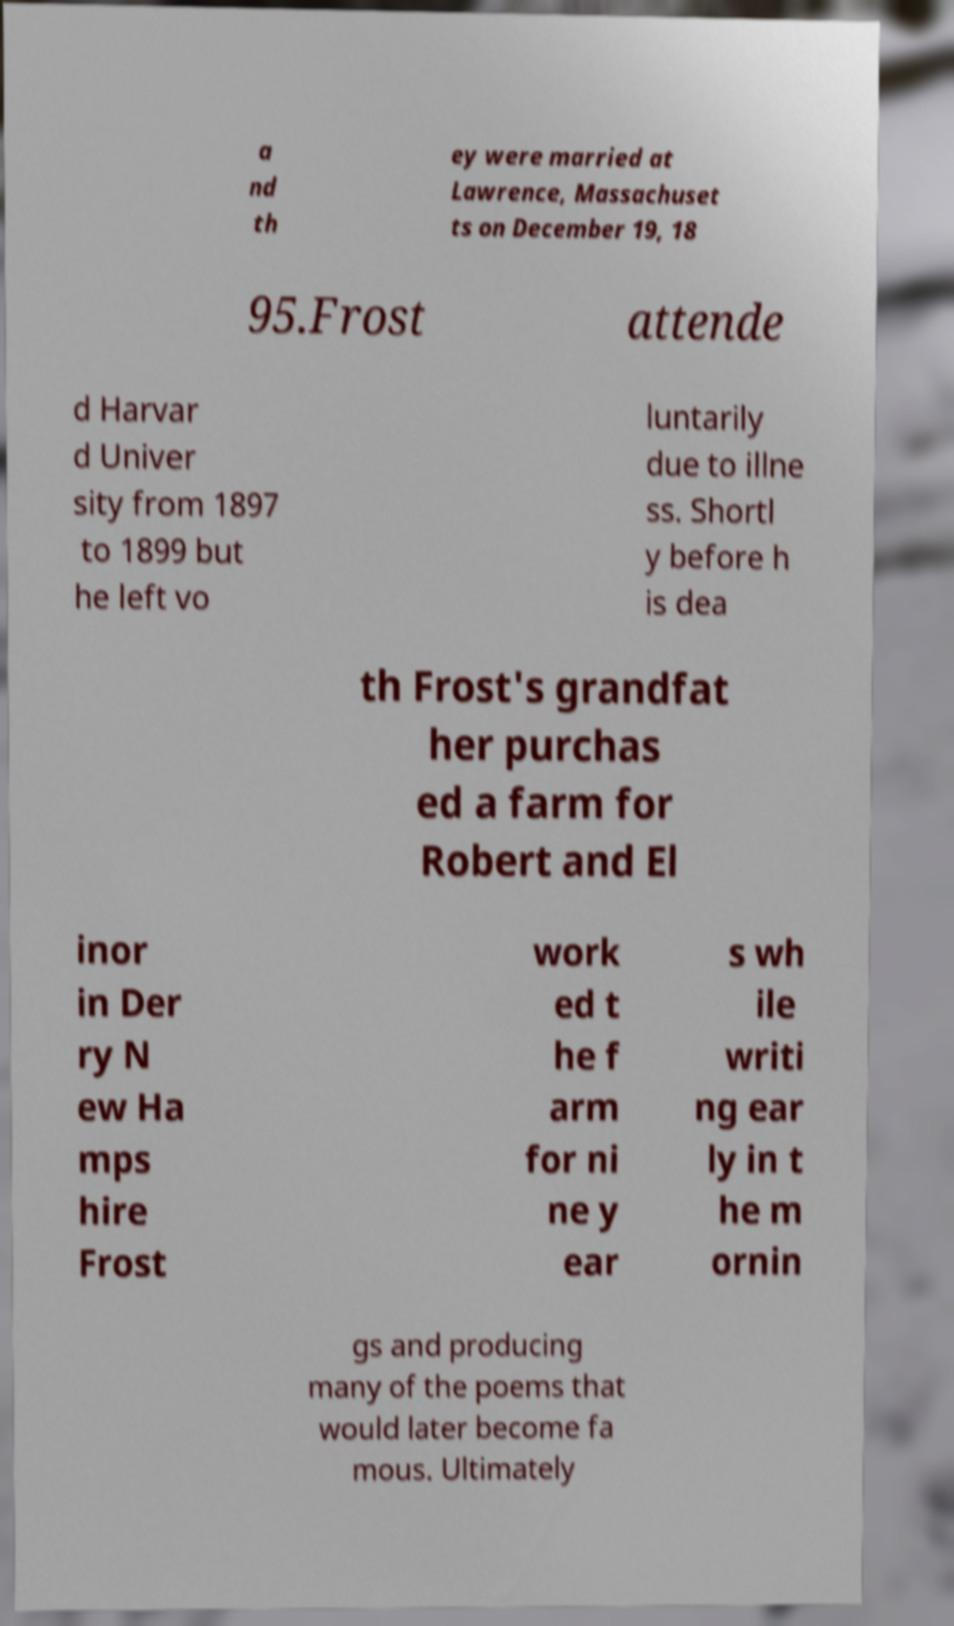Please read and relay the text visible in this image. What does it say? a nd th ey were married at Lawrence, Massachuset ts on December 19, 18 95.Frost attende d Harvar d Univer sity from 1897 to 1899 but he left vo luntarily due to illne ss. Shortl y before h is dea th Frost's grandfat her purchas ed a farm for Robert and El inor in Der ry N ew Ha mps hire Frost work ed t he f arm for ni ne y ear s wh ile writi ng ear ly in t he m ornin gs and producing many of the poems that would later become fa mous. Ultimately 